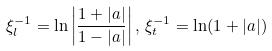Convert formula to latex. <formula><loc_0><loc_0><loc_500><loc_500>\xi _ { l } ^ { - 1 } = \ln \left | \frac { 1 + | a | } { 1 - | a | } \right | , \, \xi _ { t } ^ { - 1 } = \ln ( 1 + | a | )</formula> 